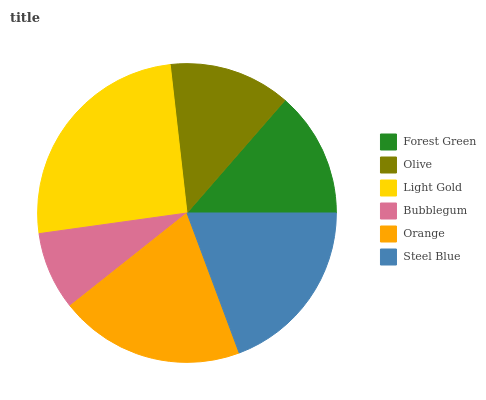Is Bubblegum the minimum?
Answer yes or no. Yes. Is Light Gold the maximum?
Answer yes or no. Yes. Is Olive the minimum?
Answer yes or no. No. Is Olive the maximum?
Answer yes or no. No. Is Forest Green greater than Olive?
Answer yes or no. Yes. Is Olive less than Forest Green?
Answer yes or no. Yes. Is Olive greater than Forest Green?
Answer yes or no. No. Is Forest Green less than Olive?
Answer yes or no. No. Is Steel Blue the high median?
Answer yes or no. Yes. Is Forest Green the low median?
Answer yes or no. Yes. Is Bubblegum the high median?
Answer yes or no. No. Is Bubblegum the low median?
Answer yes or no. No. 